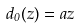Convert formula to latex. <formula><loc_0><loc_0><loc_500><loc_500>d _ { 0 } ( z ) = a z</formula> 